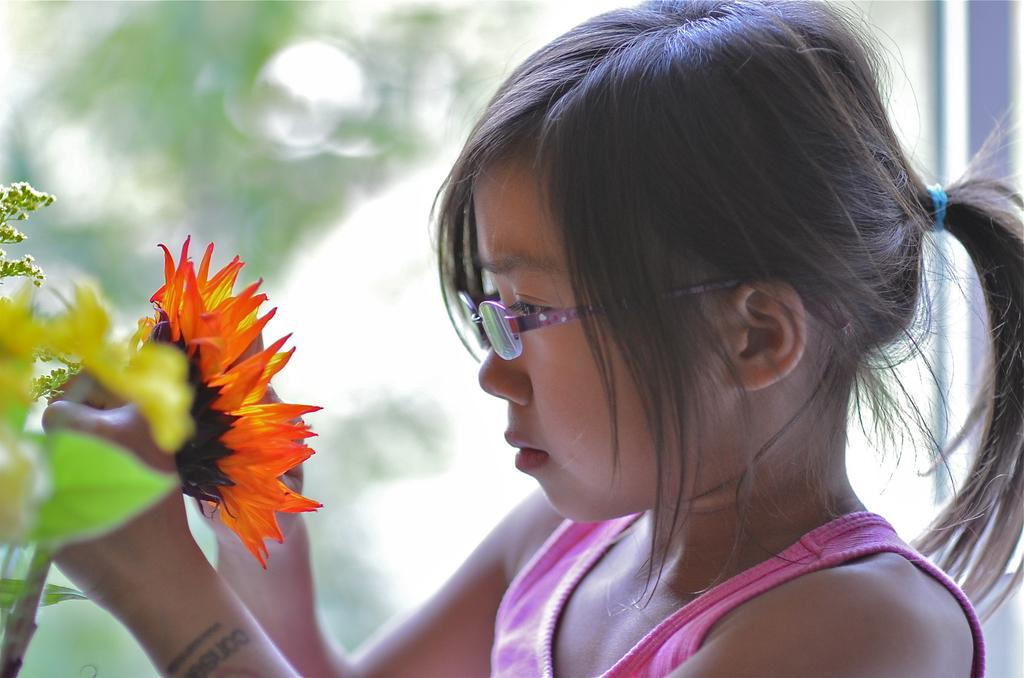Who is the main subject in the image? There is a girl in the image. What is the girl holding in the image? The girl is holding a flower. What can be seen on the left side of the image? There are flowers and leaves on the left side of the image. How would you describe the background of the image? The background of the image is blurry. Can you see the girl's lips in the image? The image does not provide a clear view of the girl's lips, as the background is blurry. 